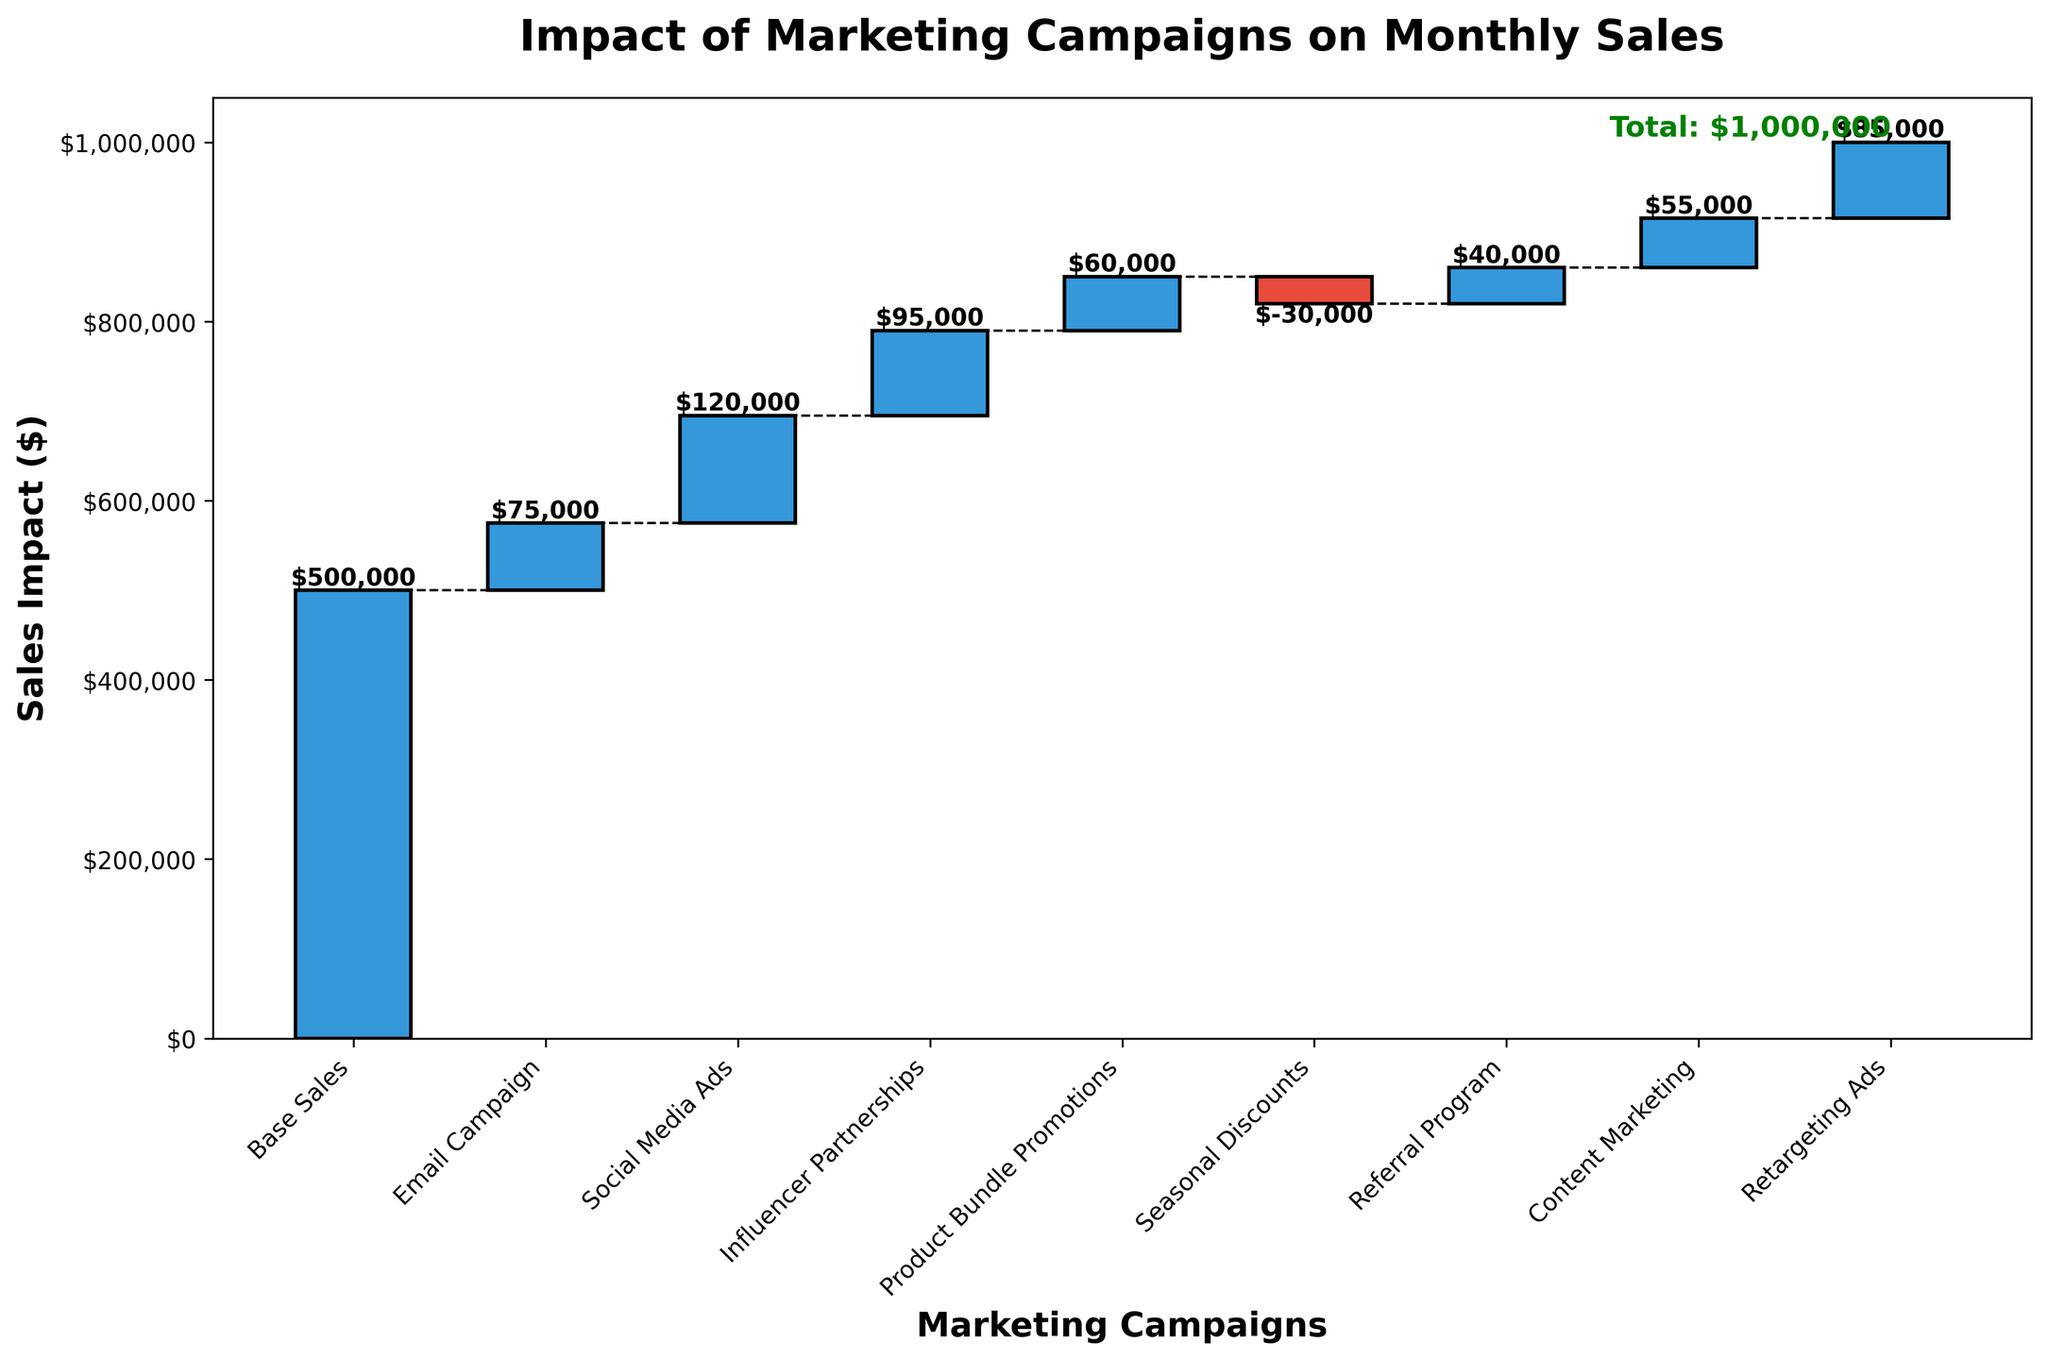What is the title of the chart? The title is located at the top of the chart and is written in bold.
Answer: Impact of Marketing Campaigns on Monthly Sales What is the y-axis label? The y-axis label is located on the left side of the chart and describes what the y-axis represents.
Answer: Sales Impact ($) How many marketing campaigns are represented in the chart? Count the number of bars in the chart, excluding the total sales. Each bar represents a marketing campaign.
Answer: 8 Which marketing campaign had the highest positive impact on sales? Look for the tallest upward bar in the chart, which signifies the highest positive impact.
Answer: Social Media Ads Which marketing campaign resulted in a decrease in sales? Identify the bar that points downwards, indicating a negative value.
Answer: Seasonal Discounts What is the total sales amount? The total sales amount is usually indicated at the end of the cumulative sum line or in a text label at the end.
Answer: $1,000,000 What is the combined impact of Product Bundle Promotions and Referral Program? Find the values of both campaigns and add them together.
Answer: $60,000 + $40,000 = $100,000 What is the difference in sales impact between Email Campaign and Influencer Partnerships? Subtract the impact value of Influencer Partnerships from Email Campaign to find the difference.
Answer: $95,000 - $75,000 = $20,000 Which two campaigns contributed equally to the total sales impact? Look for bars that have the same length, indicating equal contribution to sales.
Answer: Product Bundle Promotions and Content Marketing both contributed $55,000 each How does the impact of Retargeting Ads compare to the Email Campaign? Identify the heights of both bars and compare which one is higher.
Answer: Retargeting Ads had a higher impact at $85,000 compared to Email Campaign’s $75,000 